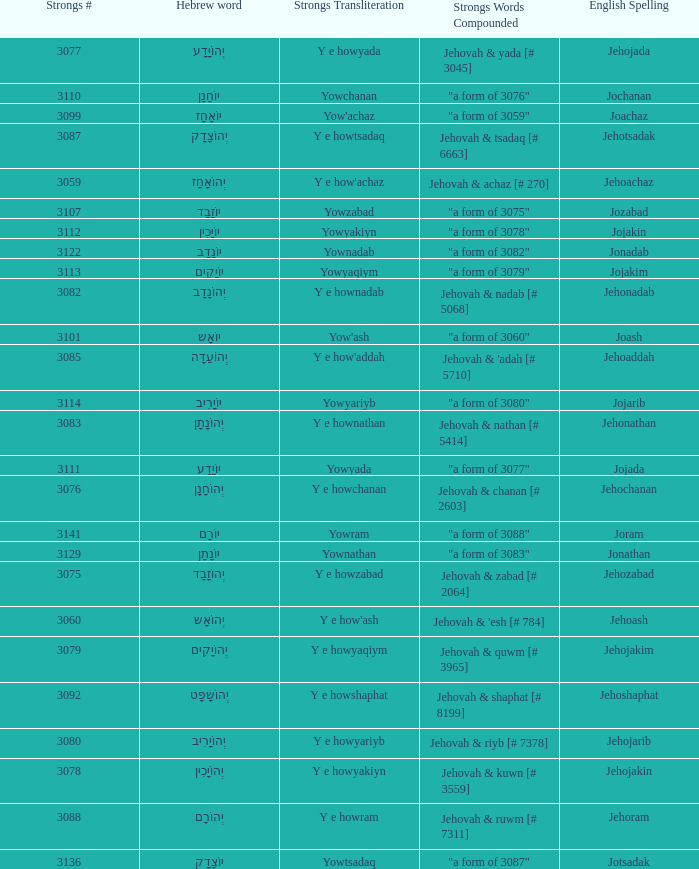What is the strongs # of the english spelling word jehojakin? 3078.0. 